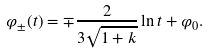<formula> <loc_0><loc_0><loc_500><loc_500>\varphi _ { \pm } ( t ) = \mp \frac { 2 } { 3 \sqrt { 1 + k } } \ln t + \varphi _ { 0 } .</formula> 